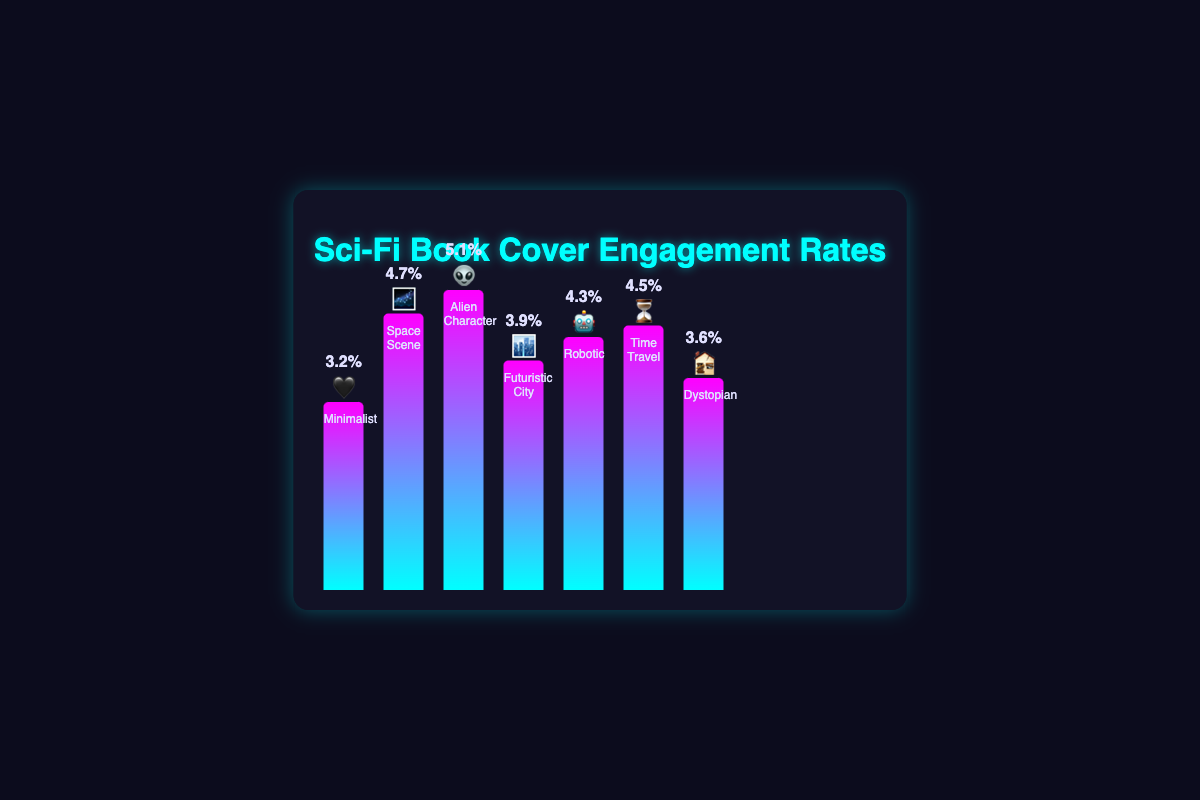What is the engagement rate for the "Alien Character 👽" cover style? The engagement rate for the "Alien Character 👽" cover style can be found directly in the figure. It is indicated by a bar with an emoji 👽 and a value displayed as 5.1%.
Answer: 5.1% Which cover style has the highest engagement rate? To find the highest engagement rate, we need to look at the bar with the maximum height. The "Alien Character 👽" cover style has the highest bar with an engagement rate of 5.1%.
Answer: Alien Character 👽 Compare the engagement rates of "Minimalist 🖤" and "Futuristic City 🏙️" cover styles. Which one has a higher engagement rate, and by how much? The engagement rate for "Minimalist 🖤" is 3.2%, and for "Futuristic City 🏙️" it is 3.9%. To find which one is higher, we subtract 3.2% from 3.9%, which gives 0.7%. Thus, "Futuristic City 🏙️" has a higher engagement rate by 0.7%.
Answer: Futuristic City 🏙️, 0.7% What is the median engagement rate of all the cover styles? First, list all engagement rates in ascending order: 3.2%, 3.6%, 3.9%, 4.3%, 4.5%, 4.7%, and 5.1%. The median is the middle value, which in this case is 4.3%.
Answer: 4.3% Between "Robotic 🤖" and "Time Travel ⏳," which cover style has a lower engagement rate? The engagement rate for "Robotic 🤖" is 4.3%, and for "Time Travel ⏳" it is 4.5%. Comparing the two, "Robotic 🤖" has a lower engagement rate.
Answer: Robotic 🤖 How many cover styles have an engagement rate higher than 4%? By examining the figure, the cover styles with engagement rates higher than 4% are "Space Scene 🌌" (4.7%), "Alien Character 👽" (5.1%), "Robotic 🤖" (4.3%), and "Time Travel ⏳" (4.5%). Thus, there are 4 cover styles with an engagement rate higher than 4%.
Answer: 4 cover styles Which cover style has the lowest engagement rate, and what is that rate? The cover style with the lowest engagement rate is determined by the shortest bar in the figure. The "Minimalist 🖤" cover style has the lowest engagement rate with 3.2%.
Answer: Minimalist 🖤, 3.2% Calculate the average engagement rate for all cover styles. To find the average engagement rate, sum all engagement rates and divide by the number of cover styles: (3.2 + 4.7 + 5.1 + 3.9 + 4.3 + 4.5 + 3.6) / 7 ≈ 4.19%. Therefore, the average engagement rate is approximately 4.19%.
Answer: 4.19% What is the difference in engagement rate between "Dystopian 🏚️" and "Space Scene 🌌" cover styles? The engagement rate for "Dystopian 🏚️" is 3.6%, and for "Space Scene 🌌" it is 4.7%. The difference is 4.7% - 3.6% = 1.1%.
Answer: 1.1% 